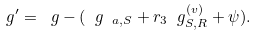<formula> <loc_0><loc_0><loc_500><loc_500>\ g ^ { \prime } = \ g - ( \ g _ { \ a , S } + r _ { 3 } \ g _ { S , R } ^ { ( v ) } + \psi ) .</formula> 